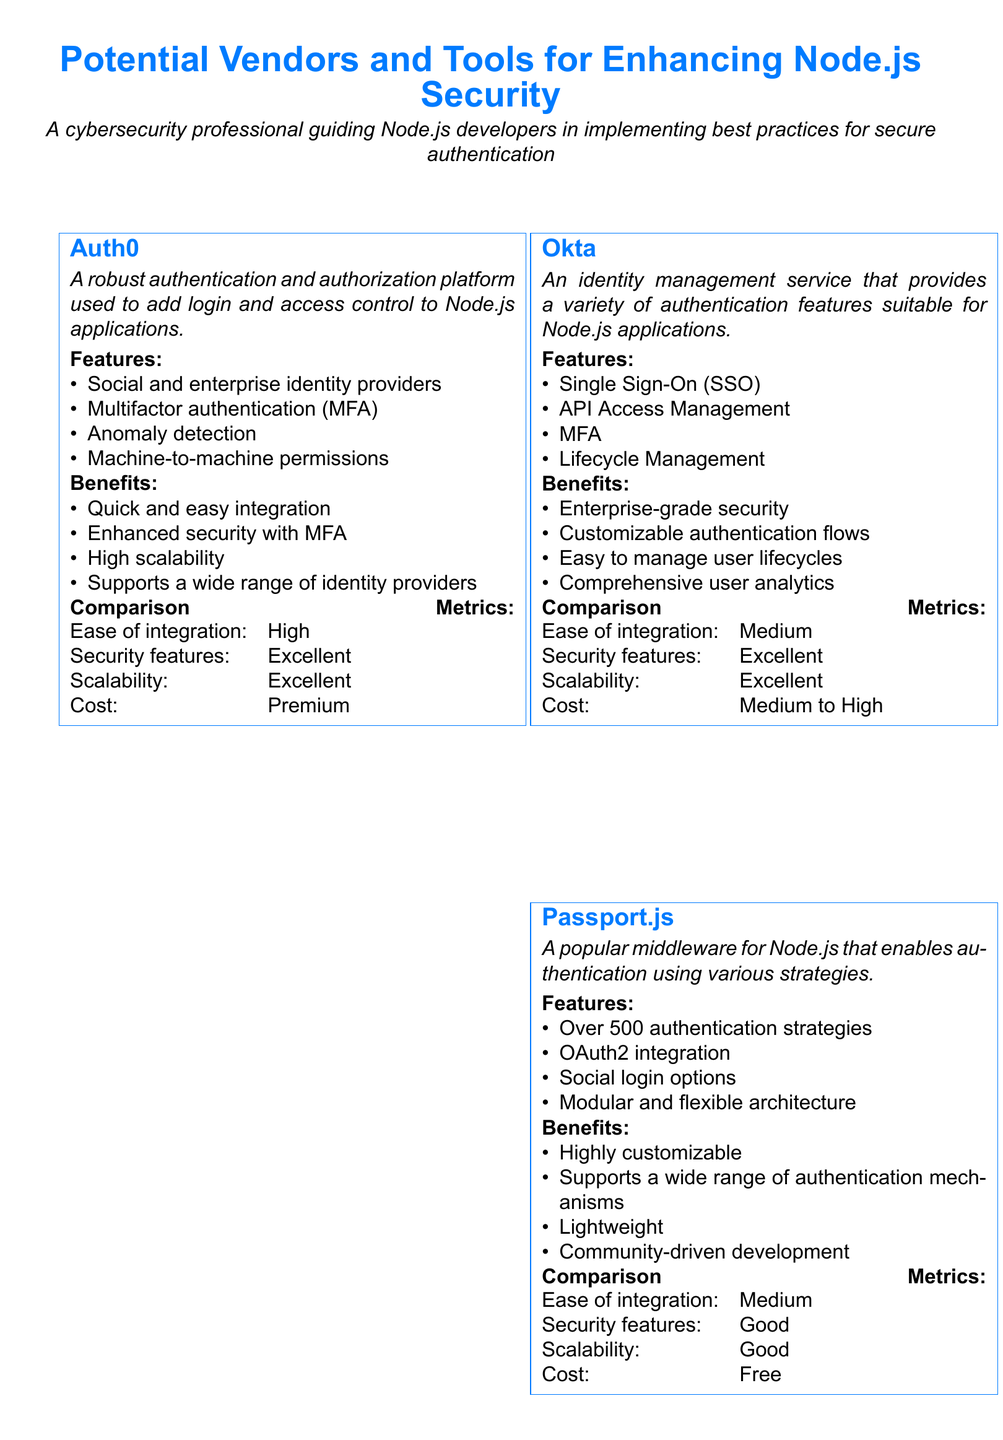What is the primary focus of the document? The document is centered around vendors and tools that enhance Node.js security, particularly in terms of secure authentication practices.
Answer: Enhancing Node.js security How many vendors are listed in the document? The document features five different vendors and tools for Node.js security.
Answer: Five Which vendor provides support for multifactor authentication? A feature for multifactor authentication is mentioned under the Auth0 vendor, highlighting its importance in securing applications.
Answer: Auth0 What is the cost classification of Passport.js? The cost aspect for Passport.js is indicated as free, making it economically accessible for developers.
Answer: Free Which vendor is known for a customizable authentication flow? The document describes Okta as offering customizable authentication flows, allowing for adaptability in user management.
Answer: Okta What security feature does Helmet offer? Helmet is highlighted for providing Content Security Policy (CSP) to protect against various online vulnerabilities.
Answer: Content Security Policy What is the ease of integration rating for Okta? The document specifies that the ease of integration for Okta is rated as medium, indicating a moderate level of complexity.
Answer: Medium Which vendor has the best scalability rating? The document indicates that JWT (jsonwebtoken) and Helmet both achieve an excellent rating for scalability, demonstrating their ability to handle growing applications.
Answer: Excellent What library is used for token-based authentication? The document identifies JWT (jsonwebtoken) as the library that facilitates token-based authentication within Node.js applications.
Answer: JWT (jsonwebtoken) 